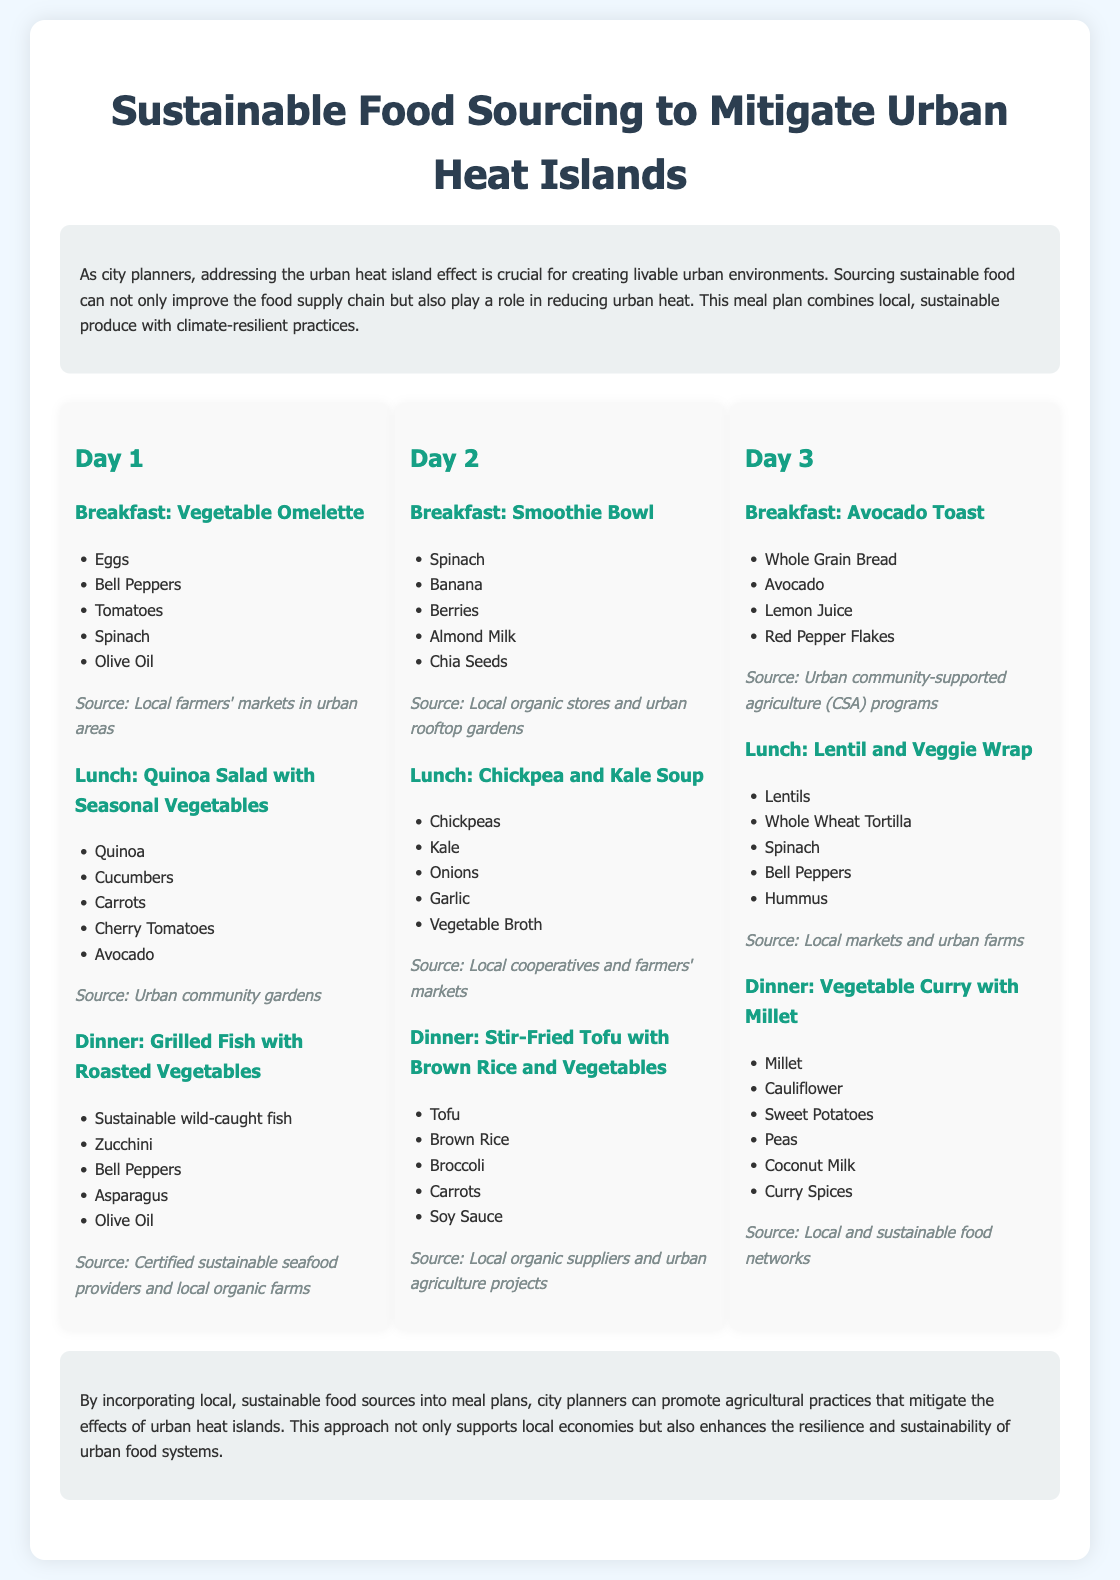What is the title of the meal plan? The title is provided at the top of the document, indicating the focus of the meal plan.
Answer: Sustainable Food Sourcing to Mitigate Urban Heat Islands What food is included in the Day 1 breakfast? The Day 1 breakfast includes a specific set of ingredients, which is listed under that meal.
Answer: Vegetable Omelette Where can the ingredients for the Day 1 lunch be sourced from? The source for the Day 1 lunch is indicated in the document after listing the meal's ingredients.
Answer: Urban community gardens How many meals are provided for each day in the meal plan? Each day's meal section consists of three distinct meals, indicated in the document structure.
Answer: Three Which type of cuisine is featured in the Day 3 dinner? The type of cuisine listed for the Day 3 dinner tells us about the dish being served.
Answer: Vegetable Curry What is the main ingredient in the Day 2 dinner? The Day 2 dinner's main component is listed, highlighting key elements of the meal.
Answer: Tofu What theme do the meals in this plan address? The theme refers to the overarching goal or method behind the meal selections presented in the document.
Answer: Sustainable food sourcing What is the source type for the Day 3 breakfast? This detail specifies the organization or location where ingredients for the breakfast can be sourced.
Answer: Urban community-supported agriculture (CSA) programs 